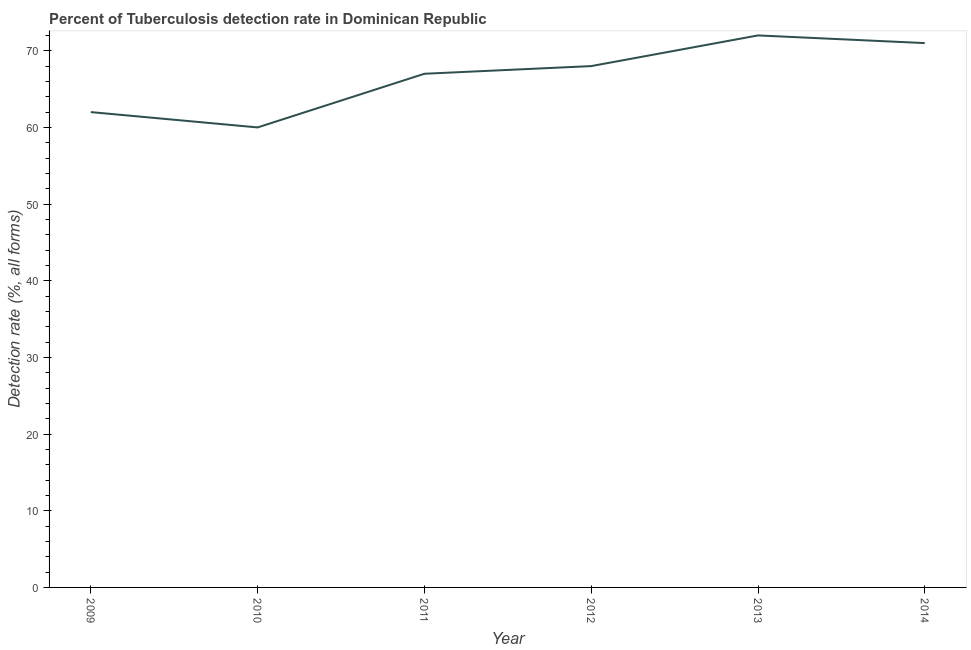What is the detection rate of tuberculosis in 2013?
Offer a very short reply. 72. Across all years, what is the maximum detection rate of tuberculosis?
Offer a very short reply. 72. Across all years, what is the minimum detection rate of tuberculosis?
Give a very brief answer. 60. What is the sum of the detection rate of tuberculosis?
Your answer should be compact. 400. What is the difference between the detection rate of tuberculosis in 2013 and 2014?
Your response must be concise. 1. What is the average detection rate of tuberculosis per year?
Make the answer very short. 66.67. What is the median detection rate of tuberculosis?
Your answer should be very brief. 67.5. Do a majority of the years between 2010 and 2009 (inclusive) have detection rate of tuberculosis greater than 40 %?
Keep it short and to the point. No. What is the ratio of the detection rate of tuberculosis in 2009 to that in 2011?
Ensure brevity in your answer.  0.93. Is the detection rate of tuberculosis in 2009 less than that in 2014?
Your answer should be very brief. Yes. Is the difference between the detection rate of tuberculosis in 2010 and 2011 greater than the difference between any two years?
Offer a terse response. No. What is the difference between the highest and the second highest detection rate of tuberculosis?
Your response must be concise. 1. What is the difference between the highest and the lowest detection rate of tuberculosis?
Provide a succinct answer. 12. Does the detection rate of tuberculosis monotonically increase over the years?
Your answer should be compact. No. How many lines are there?
Your answer should be very brief. 1. Does the graph contain grids?
Make the answer very short. No. What is the title of the graph?
Your response must be concise. Percent of Tuberculosis detection rate in Dominican Republic. What is the label or title of the X-axis?
Make the answer very short. Year. What is the label or title of the Y-axis?
Give a very brief answer. Detection rate (%, all forms). What is the Detection rate (%, all forms) in 2009?
Make the answer very short. 62. What is the Detection rate (%, all forms) of 2010?
Offer a very short reply. 60. What is the Detection rate (%, all forms) of 2013?
Ensure brevity in your answer.  72. What is the difference between the Detection rate (%, all forms) in 2009 and 2010?
Your response must be concise. 2. What is the difference between the Detection rate (%, all forms) in 2009 and 2011?
Offer a very short reply. -5. What is the difference between the Detection rate (%, all forms) in 2009 and 2012?
Offer a terse response. -6. What is the difference between the Detection rate (%, all forms) in 2009 and 2014?
Your answer should be very brief. -9. What is the difference between the Detection rate (%, all forms) in 2010 and 2011?
Your answer should be compact. -7. What is the difference between the Detection rate (%, all forms) in 2010 and 2012?
Provide a short and direct response. -8. What is the difference between the Detection rate (%, all forms) in 2010 and 2013?
Keep it short and to the point. -12. What is the difference between the Detection rate (%, all forms) in 2010 and 2014?
Give a very brief answer. -11. What is the difference between the Detection rate (%, all forms) in 2011 and 2013?
Your response must be concise. -5. What is the difference between the Detection rate (%, all forms) in 2012 and 2014?
Your response must be concise. -3. What is the ratio of the Detection rate (%, all forms) in 2009 to that in 2010?
Make the answer very short. 1.03. What is the ratio of the Detection rate (%, all forms) in 2009 to that in 2011?
Give a very brief answer. 0.93. What is the ratio of the Detection rate (%, all forms) in 2009 to that in 2012?
Provide a succinct answer. 0.91. What is the ratio of the Detection rate (%, all forms) in 2009 to that in 2013?
Provide a short and direct response. 0.86. What is the ratio of the Detection rate (%, all forms) in 2009 to that in 2014?
Provide a short and direct response. 0.87. What is the ratio of the Detection rate (%, all forms) in 2010 to that in 2011?
Your answer should be very brief. 0.9. What is the ratio of the Detection rate (%, all forms) in 2010 to that in 2012?
Your answer should be very brief. 0.88. What is the ratio of the Detection rate (%, all forms) in 2010 to that in 2013?
Your answer should be very brief. 0.83. What is the ratio of the Detection rate (%, all forms) in 2010 to that in 2014?
Give a very brief answer. 0.84. What is the ratio of the Detection rate (%, all forms) in 2011 to that in 2012?
Make the answer very short. 0.98. What is the ratio of the Detection rate (%, all forms) in 2011 to that in 2013?
Your answer should be compact. 0.93. What is the ratio of the Detection rate (%, all forms) in 2011 to that in 2014?
Offer a very short reply. 0.94. What is the ratio of the Detection rate (%, all forms) in 2012 to that in 2013?
Make the answer very short. 0.94. What is the ratio of the Detection rate (%, all forms) in 2012 to that in 2014?
Keep it short and to the point. 0.96. 